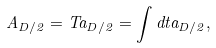Convert formula to latex. <formula><loc_0><loc_0><loc_500><loc_500>A _ { D / 2 } = T a _ { D / 2 } = \int d t a _ { D / 2 } ,</formula> 